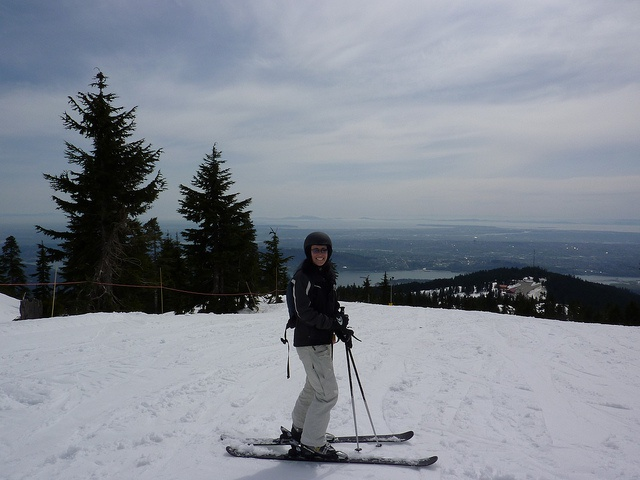Describe the objects in this image and their specific colors. I can see people in gray, black, darkgray, and maroon tones and skis in gray, black, and darkgray tones in this image. 